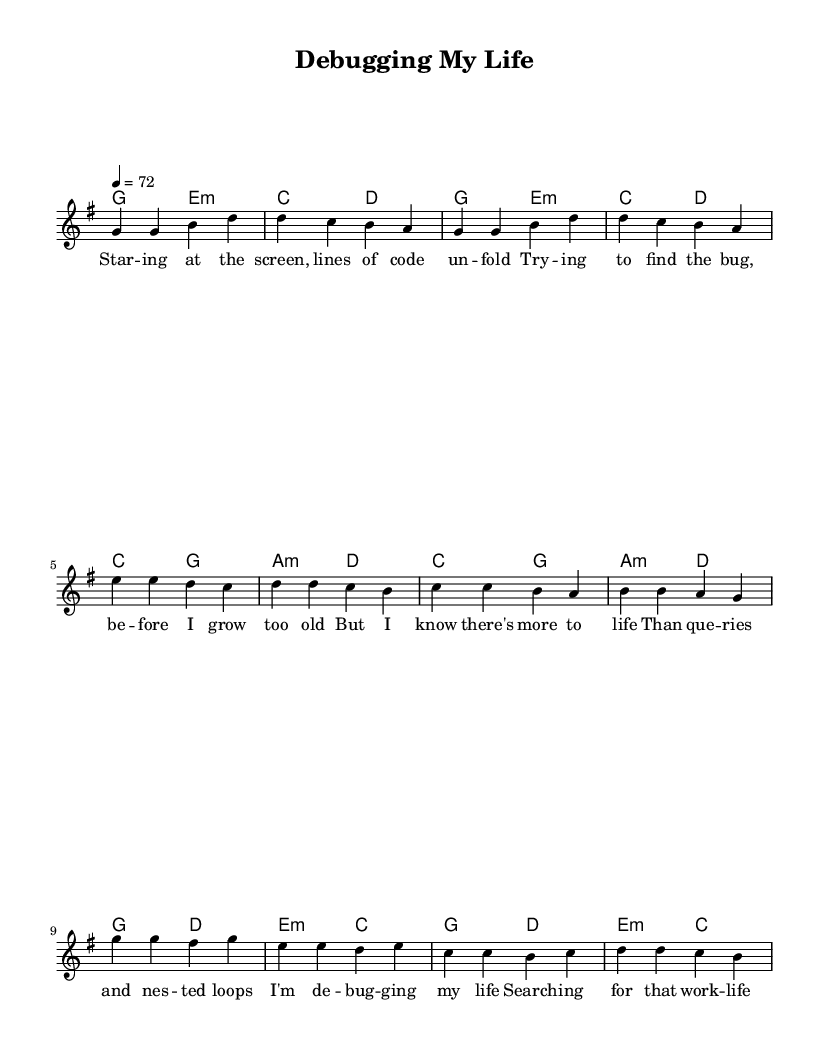What is the key signature of this music? The key signature shown in the sheet music is G major, which has one sharp (F#). This can be determined by looking at the key signature section located at the beginning of the staff.
Answer: G major What is the time signature of this piece? The time signature displayed in the music is 4/4, indicating four beats per measure. This can be seen at the beginning of the staff, just after the key signature.
Answer: 4/4 What is the tempo marking for the piece? The tempo marking is 72 beats per minute. This is indicated above the staff, specifying how quickly the music should be played.
Answer: 72 How many measures are in the chorus section? The chorus consists of 4 measures, as can be counted by analyzing the notation in the chorus section of the sheet music. Each measure is separated by vertical lines.
Answer: 4 What are the first two chords in the verse? The first two chords presented in the verse are G major and E minor. They are found in the harmony section directly beneath the melody line for the verse.
Answer: G major, E minor How does the melody move in the first two measures of the verse? In the first two measures of the verse, the melody moves from G to G and then ascends to B and finally climbs to D. This melodic movement is reflected in the notes written on the staff.
Answer: G to D What theme does the lyrics reflect in the chorus? The lyrics in the chorus reflect a theme of seeking balance in life amidst the pressures of work, particularly in the tech industry. This is inferred from the content of the lyrics, which discuss "debugging my life" and searching for a "work-life splice."
Answer: Work-life balance 